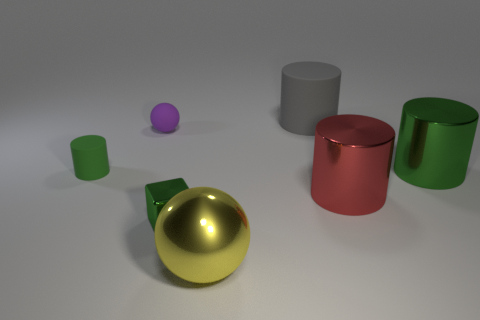There is a small sphere behind the cylinder that is to the left of the purple matte object that is behind the tiny green cylinder; what is it made of? The small sphere appears to be made of a shiny material, potentially metal or plastic, given its high reflectivity and smooth surface. 